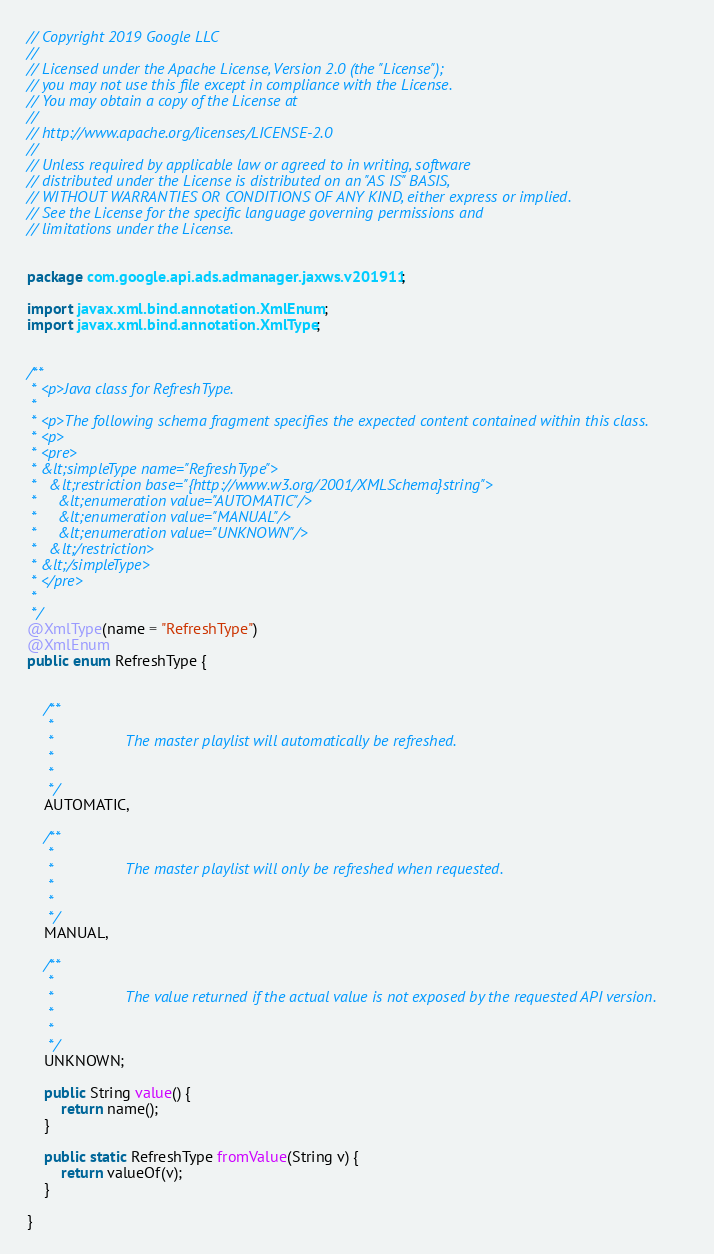Convert code to text. <code><loc_0><loc_0><loc_500><loc_500><_Java_>// Copyright 2019 Google LLC
//
// Licensed under the Apache License, Version 2.0 (the "License");
// you may not use this file except in compliance with the License.
// You may obtain a copy of the License at
//
// http://www.apache.org/licenses/LICENSE-2.0
//
// Unless required by applicable law or agreed to in writing, software
// distributed under the License is distributed on an "AS IS" BASIS,
// WITHOUT WARRANTIES OR CONDITIONS OF ANY KIND, either express or implied.
// See the License for the specific language governing permissions and
// limitations under the License.


package com.google.api.ads.admanager.jaxws.v201911;

import javax.xml.bind.annotation.XmlEnum;
import javax.xml.bind.annotation.XmlType;


/**
 * <p>Java class for RefreshType.
 * 
 * <p>The following schema fragment specifies the expected content contained within this class.
 * <p>
 * <pre>
 * &lt;simpleType name="RefreshType">
 *   &lt;restriction base="{http://www.w3.org/2001/XMLSchema}string">
 *     &lt;enumeration value="AUTOMATIC"/>
 *     &lt;enumeration value="MANUAL"/>
 *     &lt;enumeration value="UNKNOWN"/>
 *   &lt;/restriction>
 * &lt;/simpleType>
 * </pre>
 * 
 */
@XmlType(name = "RefreshType")
@XmlEnum
public enum RefreshType {


    /**
     * 
     *                 The master playlist will automatically be refreshed.
     *               
     * 
     */
    AUTOMATIC,

    /**
     * 
     *                 The master playlist will only be refreshed when requested.
     *               
     * 
     */
    MANUAL,

    /**
     * 
     *                 The value returned if the actual value is not exposed by the requested API version.
     *               
     * 
     */
    UNKNOWN;

    public String value() {
        return name();
    }

    public static RefreshType fromValue(String v) {
        return valueOf(v);
    }

}
</code> 